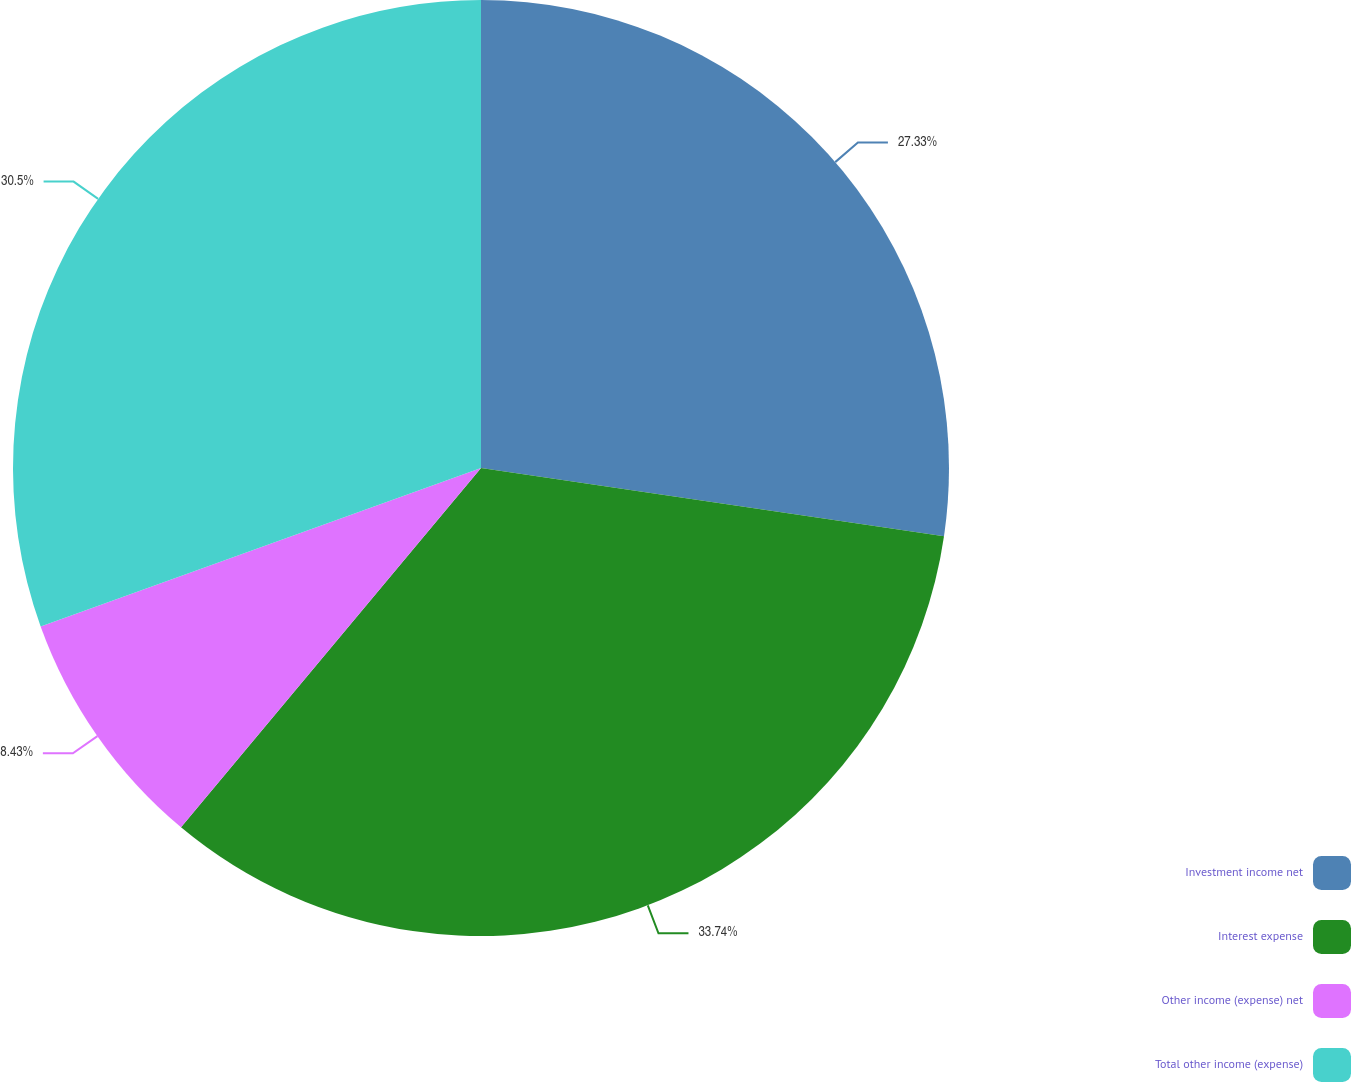Convert chart to OTSL. <chart><loc_0><loc_0><loc_500><loc_500><pie_chart><fcel>Investment income net<fcel>Interest expense<fcel>Other income (expense) net<fcel>Total other income (expense)<nl><fcel>27.33%<fcel>33.75%<fcel>8.43%<fcel>30.5%<nl></chart> 